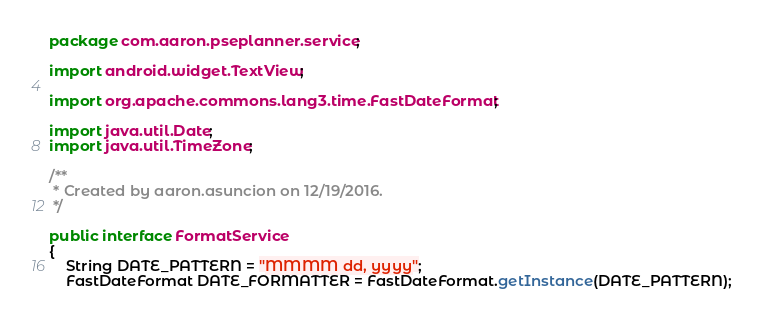<code> <loc_0><loc_0><loc_500><loc_500><_Java_>package com.aaron.pseplanner.service;

import android.widget.TextView;

import org.apache.commons.lang3.time.FastDateFormat;

import java.util.Date;
import java.util.TimeZone;

/**
 * Created by aaron.asuncion on 12/19/2016.
 */

public interface FormatService
{
    String DATE_PATTERN = "MMMM dd, yyyy";
    FastDateFormat DATE_FORMATTER = FastDateFormat.getInstance(DATE_PATTERN);
</code> 